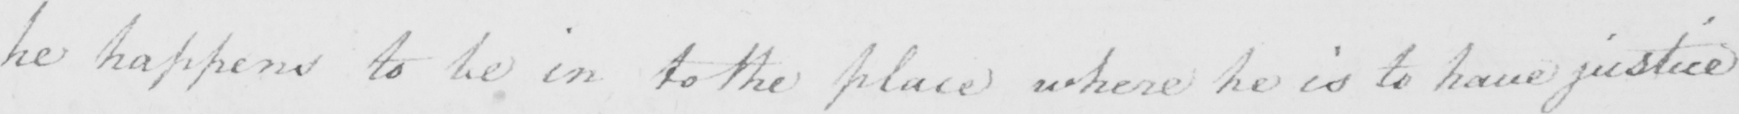What text is written in this handwritten line? he happens to be in to the place where he is to have justice 